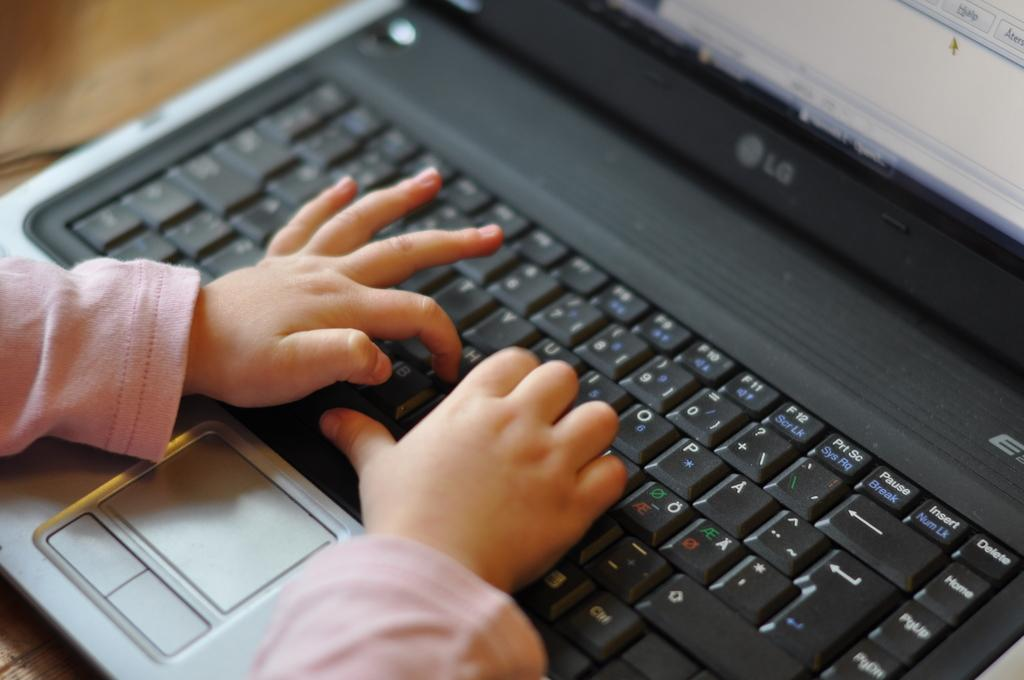<image>
Share a concise interpretation of the image provided. A small child types at the keyboard on an LG laptop. 